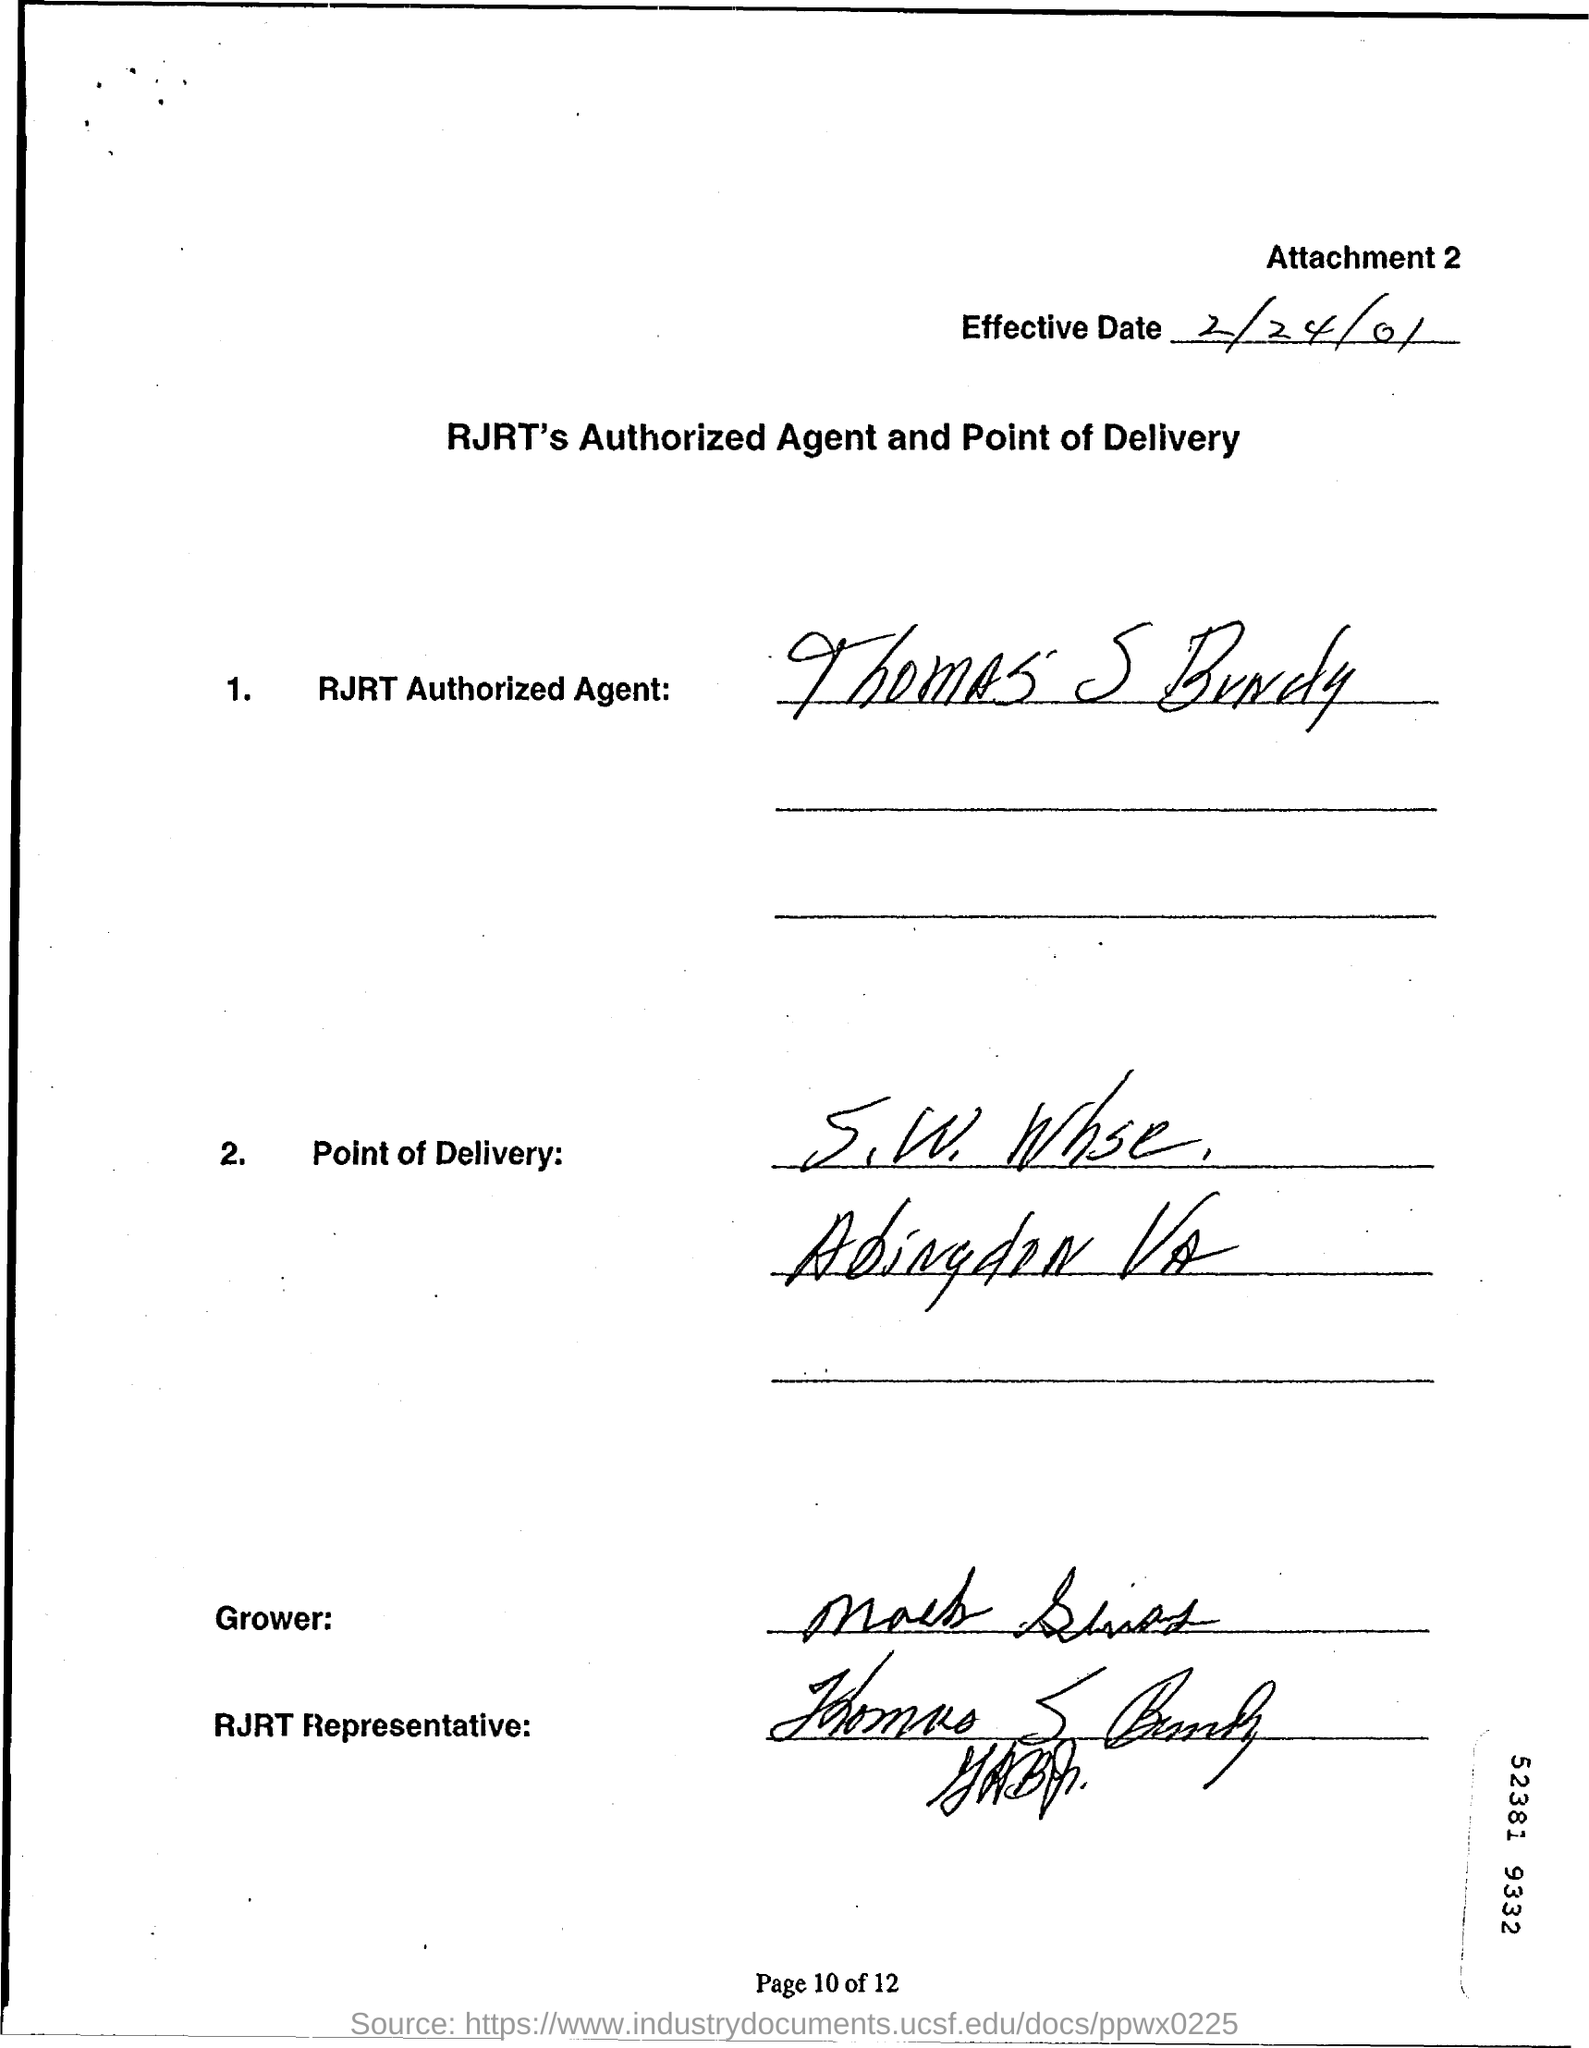Indicate a few pertinent items in this graphic. The "effective date" written at the top of the document is 2/24/01. 